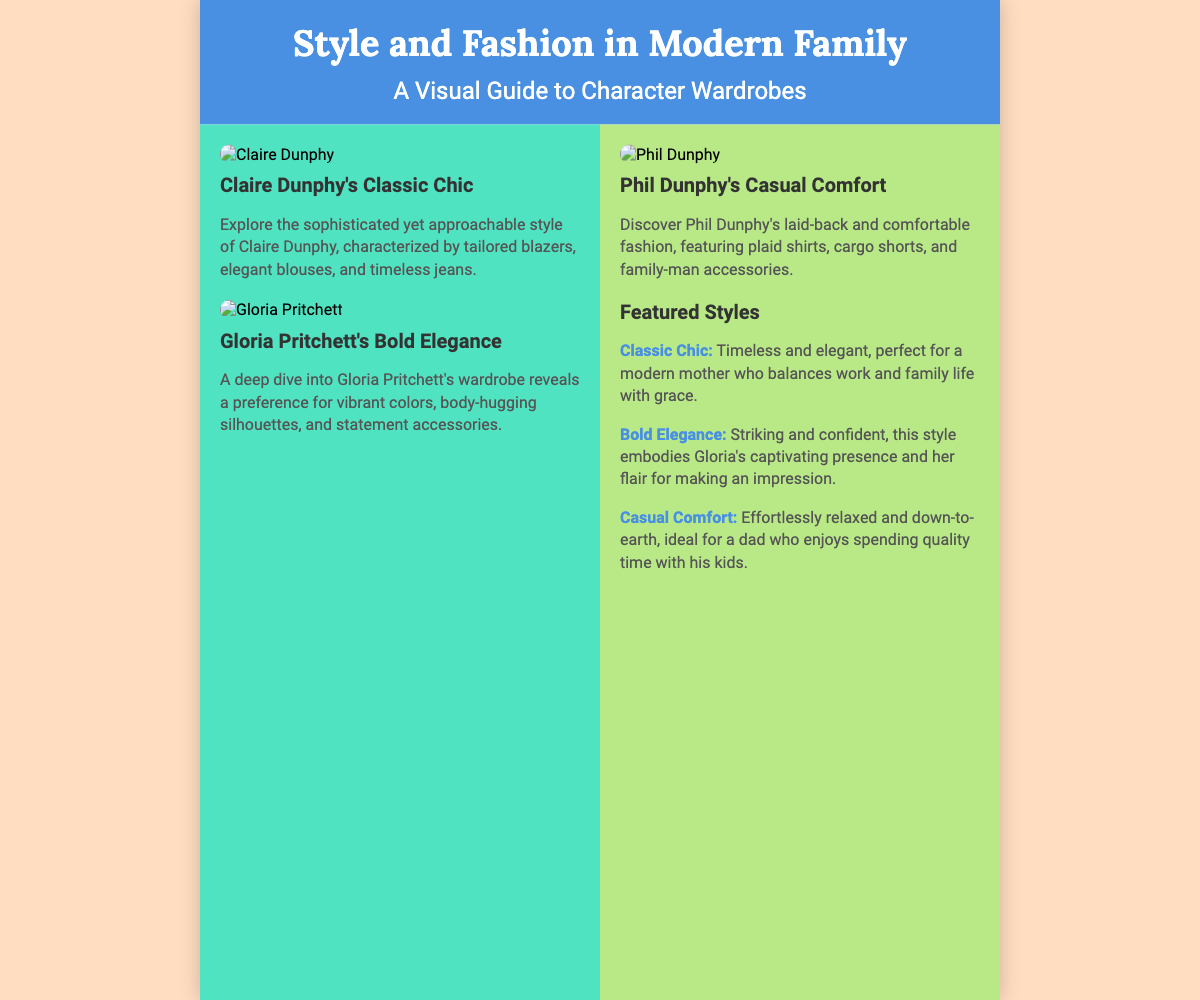What is the title of the book? The title of the book is prominently displayed in the header section of the document.
Answer: Style and Fashion in Modern Family Who is featured in Claire Dunphy's fashion description? Claire Dunphy is mentioned specifically in the highlight section about her style.
Answer: Claire Dunphy What style does Gloria Pritchett embody? Gloria Pritchett's highlight explains her fashion preferences and style characteristics.
Answer: Bold Elegance What type of clothing is associated with Phil Dunphy? The text describes Phil Dunphy's wardrobe specifics, including types of clothing he wears.
Answer: Plaid shirts How many character wardrobes are highlighted in the left column? The left column contains two specific characters with fashion descriptions.
Answer: Two What color is associated with the header of the book cover? The header background color is specified in the style section of the document.
Answer: Blue Which character's style is described as Classic Chic? The text provides a specific section showcasing a character's style description.
Answer: Claire Dunphy What fashion type is described as 'Effortlessly relaxed'? This description is found within the featured styles section, relating to Phil Dunphy's wardrobe.
Answer: Casual Comfort How many styles are featured in the styles section? The text lists out each style described in the featured styles section.
Answer: Three 